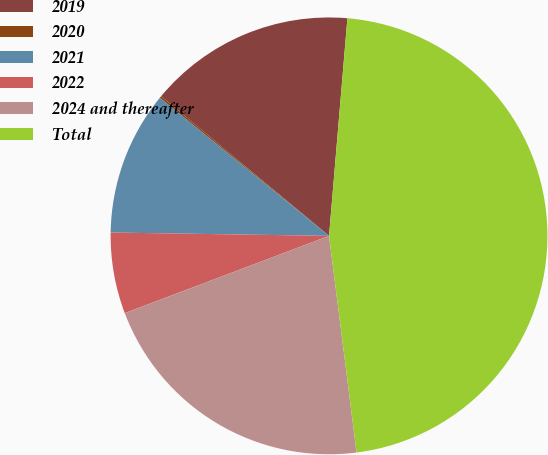Convert chart. <chart><loc_0><loc_0><loc_500><loc_500><pie_chart><fcel>2019<fcel>2020<fcel>2021<fcel>2022<fcel>2024 and thereafter<fcel>Total<nl><fcel>15.3%<fcel>0.15%<fcel>10.65%<fcel>6.0%<fcel>21.26%<fcel>46.65%<nl></chart> 